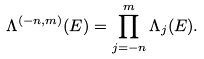Convert formula to latex. <formula><loc_0><loc_0><loc_500><loc_500>\Lambda ^ { ( - n , m ) } ( E ) = \prod _ { j = - n } ^ { m } \Lambda _ { j } ( E ) .</formula> 